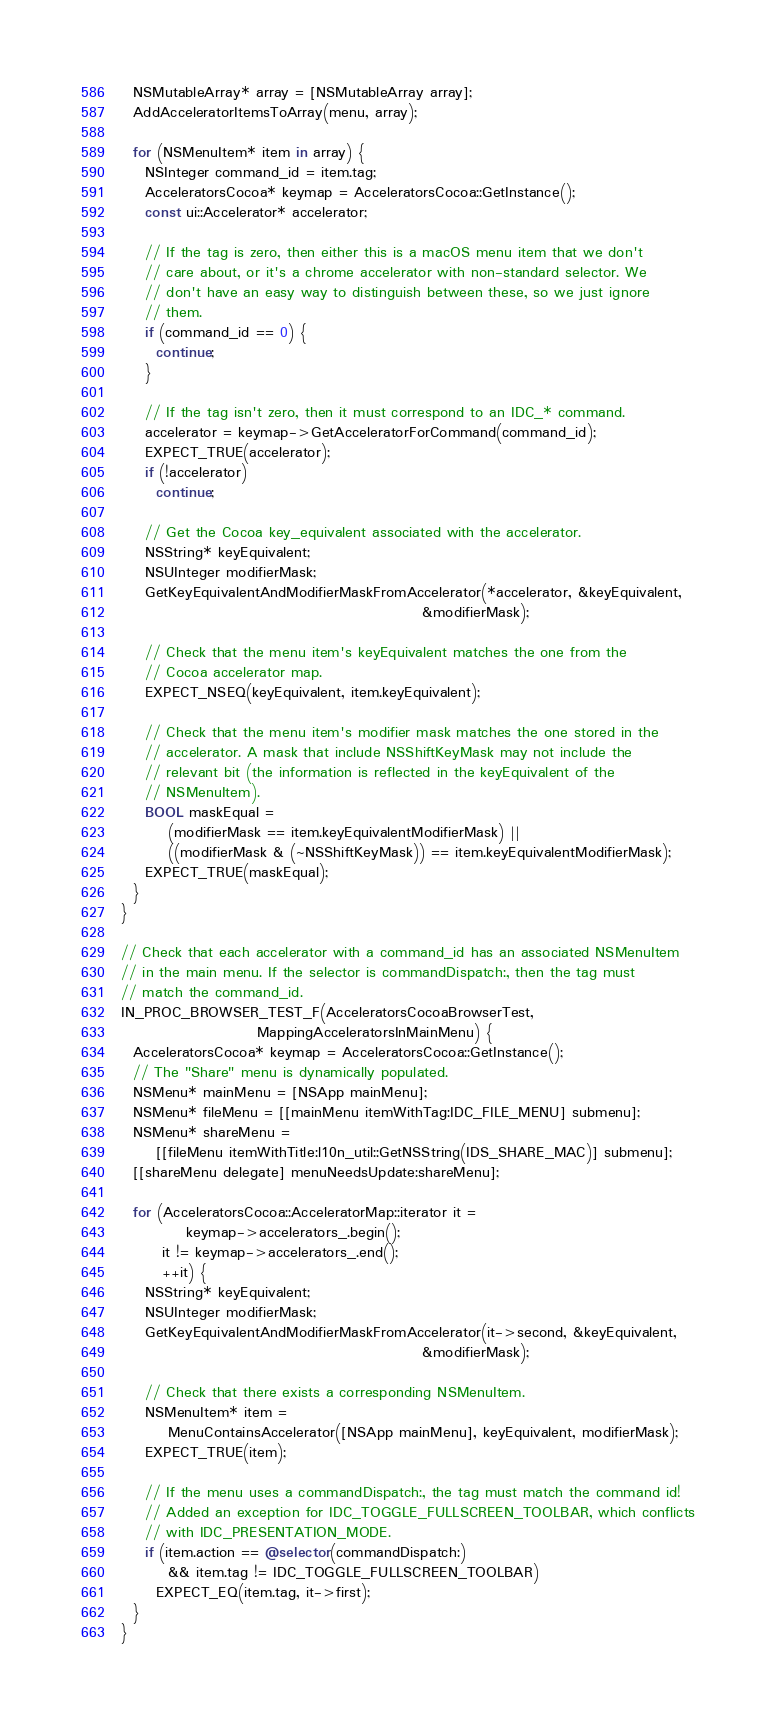Convert code to text. <code><loc_0><loc_0><loc_500><loc_500><_ObjectiveC_>  NSMutableArray* array = [NSMutableArray array];
  AddAcceleratorItemsToArray(menu, array);

  for (NSMenuItem* item in array) {
    NSInteger command_id = item.tag;
    AcceleratorsCocoa* keymap = AcceleratorsCocoa::GetInstance();
    const ui::Accelerator* accelerator;

    // If the tag is zero, then either this is a macOS menu item that we don't
    // care about, or it's a chrome accelerator with non-standard selector. We
    // don't have an easy way to distinguish between these, so we just ignore
    // them.
    if (command_id == 0) {
      continue;
    }

    // If the tag isn't zero, then it must correspond to an IDC_* command.
    accelerator = keymap->GetAcceleratorForCommand(command_id);
    EXPECT_TRUE(accelerator);
    if (!accelerator)
      continue;

    // Get the Cocoa key_equivalent associated with the accelerator.
    NSString* keyEquivalent;
    NSUInteger modifierMask;
    GetKeyEquivalentAndModifierMaskFromAccelerator(*accelerator, &keyEquivalent,
                                                   &modifierMask);

    // Check that the menu item's keyEquivalent matches the one from the
    // Cocoa accelerator map.
    EXPECT_NSEQ(keyEquivalent, item.keyEquivalent);

    // Check that the menu item's modifier mask matches the one stored in the
    // accelerator. A mask that include NSShiftKeyMask may not include the
    // relevant bit (the information is reflected in the keyEquivalent of the
    // NSMenuItem).
    BOOL maskEqual =
        (modifierMask == item.keyEquivalentModifierMask) ||
        ((modifierMask & (~NSShiftKeyMask)) == item.keyEquivalentModifierMask);
    EXPECT_TRUE(maskEqual);
  }
}

// Check that each accelerator with a command_id has an associated NSMenuItem
// in the main menu. If the selector is commandDispatch:, then the tag must
// match the command_id.
IN_PROC_BROWSER_TEST_F(AcceleratorsCocoaBrowserTest,
                       MappingAcceleratorsInMainMenu) {
  AcceleratorsCocoa* keymap = AcceleratorsCocoa::GetInstance();
  // The "Share" menu is dynamically populated.
  NSMenu* mainMenu = [NSApp mainMenu];
  NSMenu* fileMenu = [[mainMenu itemWithTag:IDC_FILE_MENU] submenu];
  NSMenu* shareMenu =
      [[fileMenu itemWithTitle:l10n_util::GetNSString(IDS_SHARE_MAC)] submenu];
  [[shareMenu delegate] menuNeedsUpdate:shareMenu];

  for (AcceleratorsCocoa::AcceleratorMap::iterator it =
           keymap->accelerators_.begin();
       it != keymap->accelerators_.end();
       ++it) {
    NSString* keyEquivalent;
    NSUInteger modifierMask;
    GetKeyEquivalentAndModifierMaskFromAccelerator(it->second, &keyEquivalent,
                                                   &modifierMask);

    // Check that there exists a corresponding NSMenuItem.
    NSMenuItem* item =
        MenuContainsAccelerator([NSApp mainMenu], keyEquivalent, modifierMask);
    EXPECT_TRUE(item);

    // If the menu uses a commandDispatch:, the tag must match the command id!
    // Added an exception for IDC_TOGGLE_FULLSCREEN_TOOLBAR, which conflicts
    // with IDC_PRESENTATION_MODE.
    if (item.action == @selector(commandDispatch:)
        && item.tag != IDC_TOGGLE_FULLSCREEN_TOOLBAR)
      EXPECT_EQ(item.tag, it->first);
  }
}
</code> 